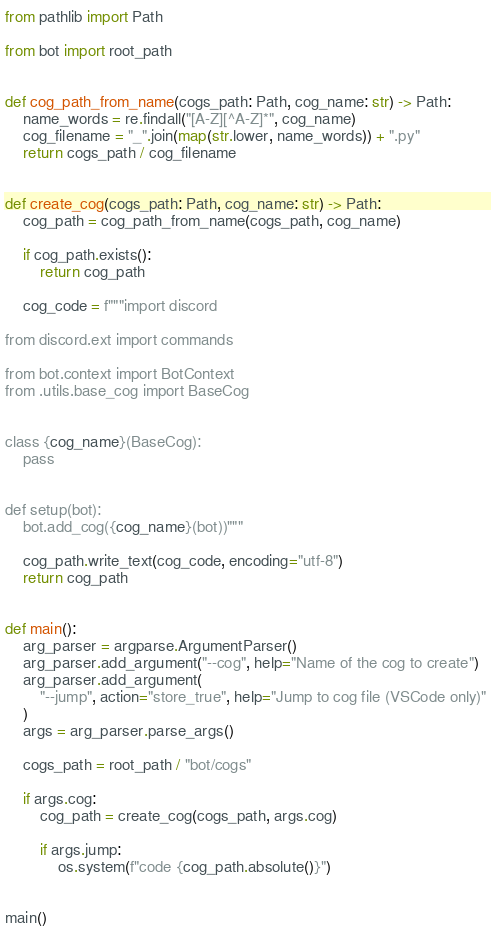<code> <loc_0><loc_0><loc_500><loc_500><_Python_>
from pathlib import Path

from bot import root_path


def cog_path_from_name(cogs_path: Path, cog_name: str) -> Path:
    name_words = re.findall("[A-Z][^A-Z]*", cog_name)
    cog_filename = "_".join(map(str.lower, name_words)) + ".py"
    return cogs_path / cog_filename


def create_cog(cogs_path: Path, cog_name: str) -> Path:
    cog_path = cog_path_from_name(cogs_path, cog_name)

    if cog_path.exists():
        return cog_path

    cog_code = f"""import discord

from discord.ext import commands

from bot.context import BotContext
from .utils.base_cog import BaseCog


class {cog_name}(BaseCog):
    pass


def setup(bot):
    bot.add_cog({cog_name}(bot))"""

    cog_path.write_text(cog_code, encoding="utf-8")
    return cog_path


def main():
    arg_parser = argparse.ArgumentParser()
    arg_parser.add_argument("--cog", help="Name of the cog to create")
    arg_parser.add_argument(
        "--jump", action="store_true", help="Jump to cog file (VSCode only)"
    )
    args = arg_parser.parse_args()

    cogs_path = root_path / "bot/cogs"

    if args.cog:
        cog_path = create_cog(cogs_path, args.cog)

        if args.jump:
            os.system(f"code {cog_path.absolute()}")


main()
</code> 